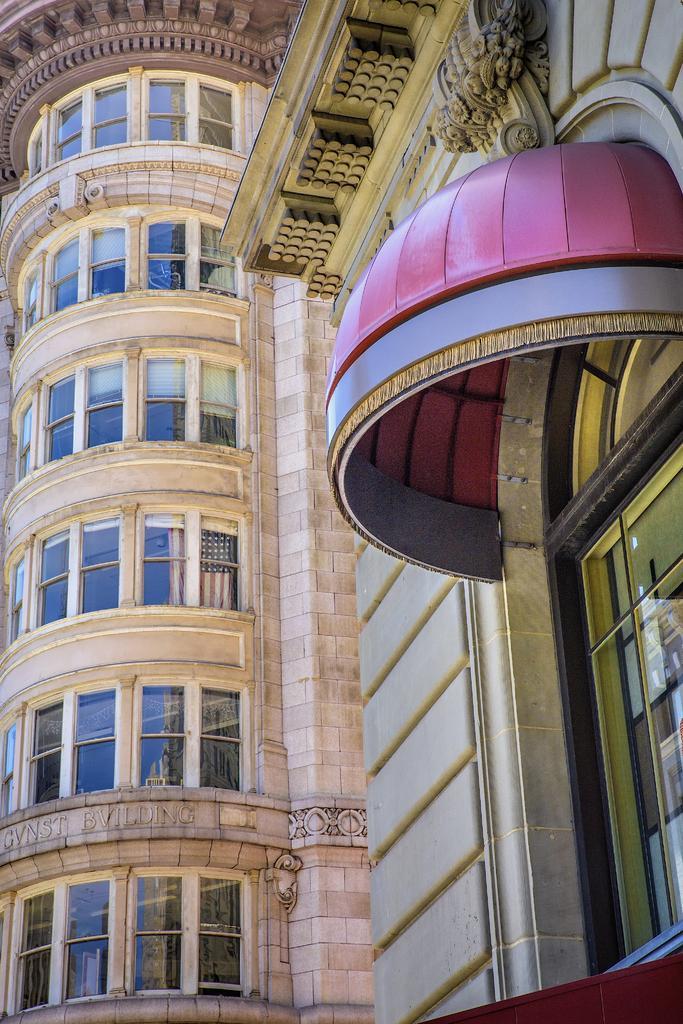Please provide a concise description of this image. In this image we can see a building with windows and roof. 